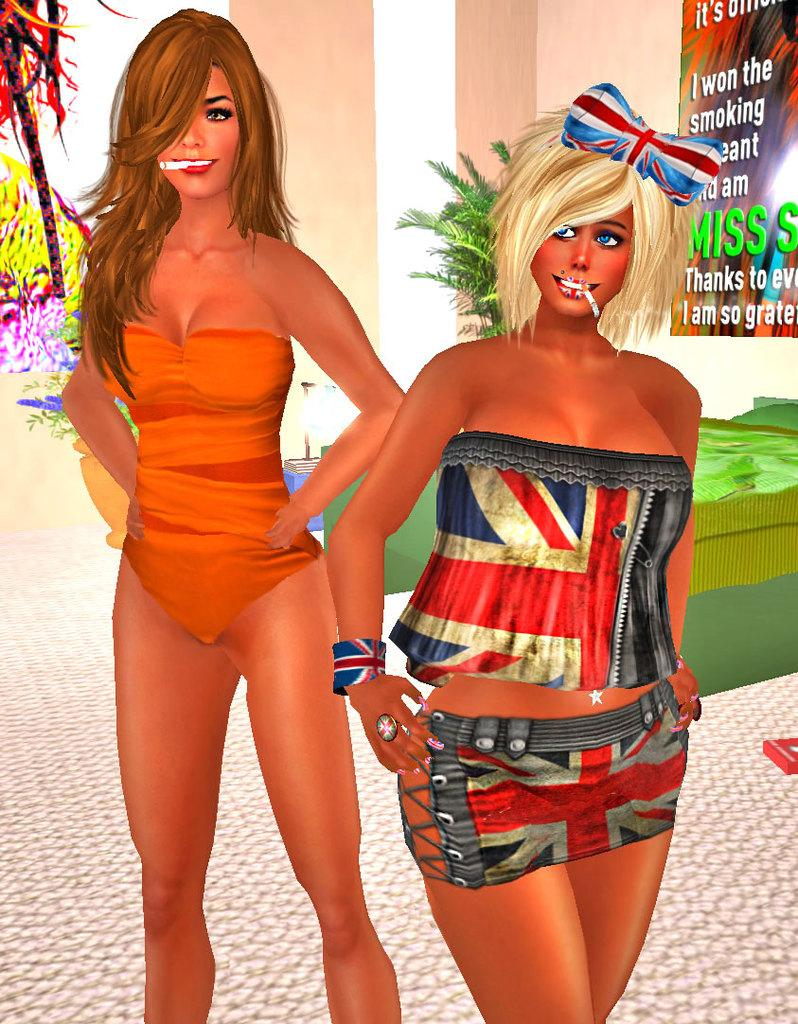How many women are in the image? There are two women in the image. What is on the wall in the image? There is a poster with text on the wall. What type of natural elements can be seen in the image? Trees are visible in the image. What is the surface beneath the women's feet in the image? The floor is present in the image. What architectural feature is present in the image? There is a pillar in the image. What living organism can be seen in the image besides the women? There is a plant in the image. What type of engine is visible in the image? There is no engine present in the image. What is the occupation of the woman on the left in the image? The provided facts do not mention the occupation of the women in the image. What is the zinc content of the plant in the image? The provided facts do not mention the zinc content of the plant in the image. 